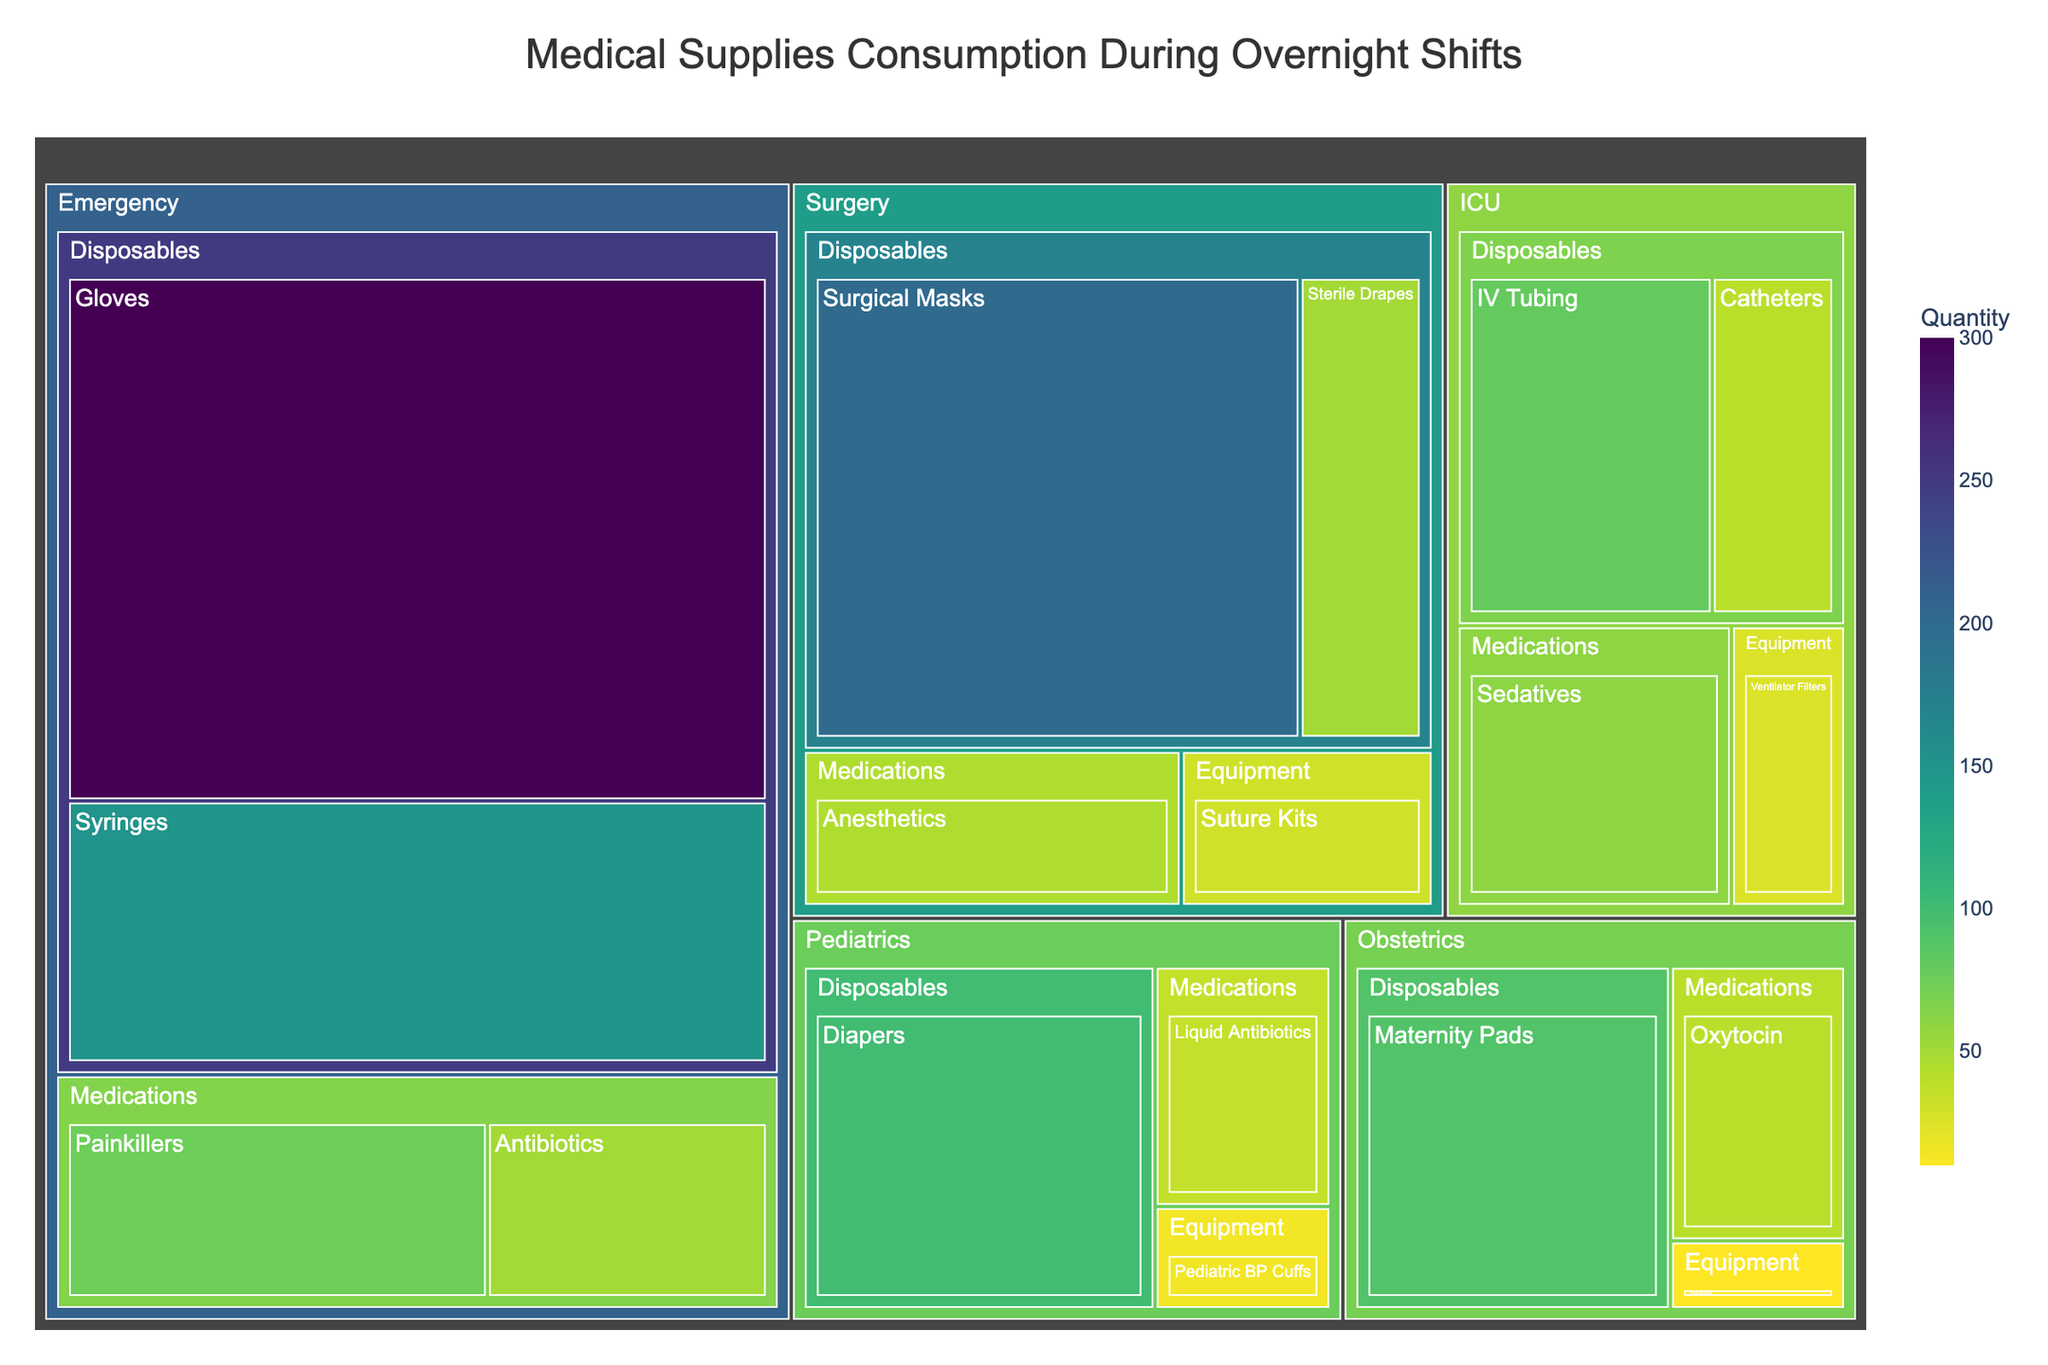What is the title of the treemap figure? The title of the treemap is located at the top and provides an overview of what the figure represents. In this case, it denotes the content and focus area of the analysis.
Answer: Medical Supplies Consumption During Overnight Shifts Which department consumes the most disposable supplies? To find the department that consumes the most disposable supplies, examine the sizes of the boxes under the 'Disposables' category for each department. The largest box represents the highest consumption.
Answer: Emergency What is the total quantity of medications consumed in the ICU department? To find the total quantity of medications consumed in the ICU, sum the quantity values for each medication item (Sedatives) listed under ICU.
Answer: 60 How does the consumption of syringes in the Emergency department compare to the total consumption of disposables in the Surgery department? Compare the quantity of syringes in the Emergency department (150) to the sum of all disposable items in the Surgery department: Surgical Masks (200) + Sterile Drapes (50) = 250.
Answer: Syringes: 150, Surgery Disposables: 250 Which item has the highest consumption in the Pediatrics department? Look at the boxes under the Pediatrics department and compare their sizes. The item with the largest box has the highest quantity.
Answer: Diapers How many different categories of supplies are consumed in the Obstetrics department? Count the unique category labels under the Obstetrics department.
Answer: 3 Which department has the smallest quantity of equipment consumption? Compare the sizes of the boxes under the Equipment category for each department. The smallest box represents the lowest consumption.
Answer: Obstetrics What is the difference in quantity between the most consumed disposable item in the Emergency department and the most consumed medication item in the Surgery department? Identify the most consumed disposable item in Emergency (Gloves: 300) and the most consumed medication in Surgery (Anesthetics: 45), and then calculate the difference: 300 - 45 = 255.
Answer: 255 Which department has a higher consumption of medications, Pediatrics or Obstetrics? Compare the total medication quantities in Pediatrics (Liquid Antibiotics: 35) and Obstetrics (Oxytocin: 40).
Answer: Obstetrics How does the consumption of ventilator filters in the ICU compare to the consumption of suture kits in the Surgery department? Compare the quantities directly by looking at the values for these two items: Ventilator Filters (25) and Suture Kits (30).
Answer: Suture Kits are 5 more than Ventilator Filters 